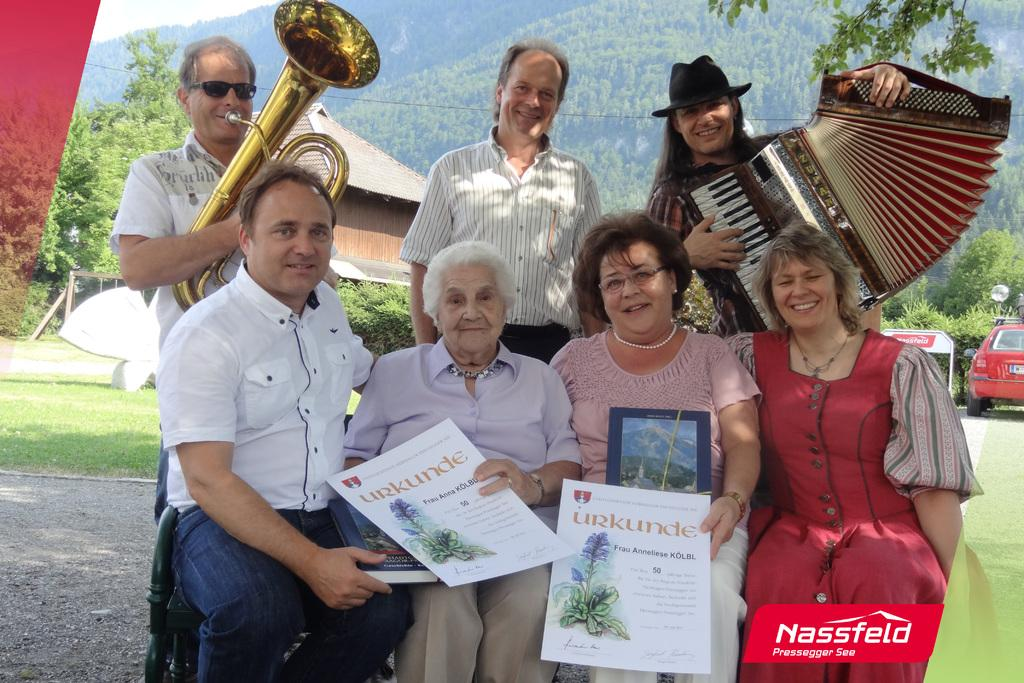<image>
Offer a succinct explanation of the picture presented. Group of people posing for a photo holding a sign that says Urkunde. 